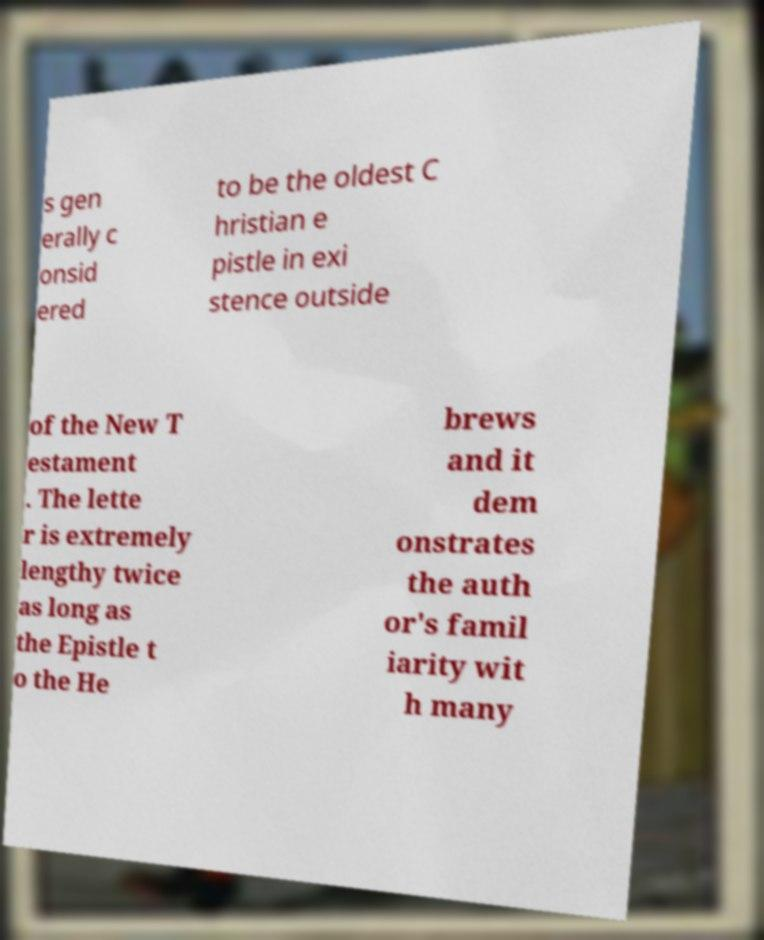For documentation purposes, I need the text within this image transcribed. Could you provide that? s gen erally c onsid ered to be the oldest C hristian e pistle in exi stence outside of the New T estament . The lette r is extremely lengthy twice as long as the Epistle t o the He brews and it dem onstrates the auth or's famil iarity wit h many 